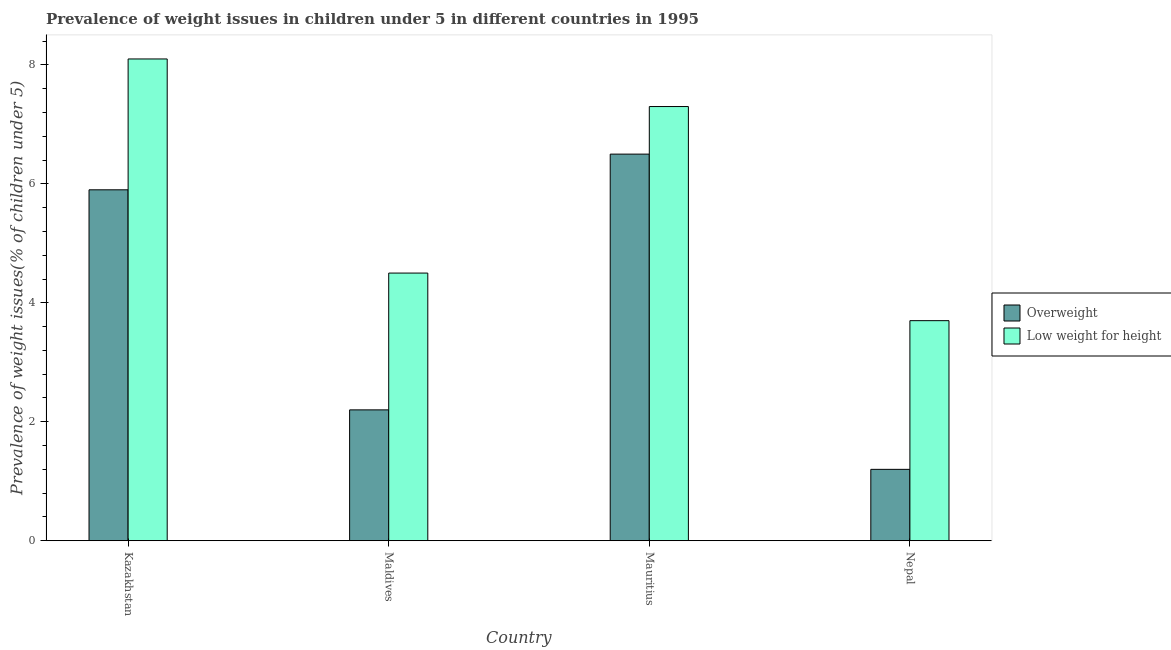How many different coloured bars are there?
Ensure brevity in your answer.  2. Are the number of bars per tick equal to the number of legend labels?
Provide a succinct answer. Yes. How many bars are there on the 4th tick from the right?
Offer a very short reply. 2. What is the label of the 1st group of bars from the left?
Make the answer very short. Kazakhstan. What is the percentage of underweight children in Nepal?
Provide a short and direct response. 3.7. Across all countries, what is the minimum percentage of underweight children?
Provide a short and direct response. 3.7. In which country was the percentage of overweight children maximum?
Give a very brief answer. Mauritius. In which country was the percentage of overweight children minimum?
Provide a succinct answer. Nepal. What is the total percentage of underweight children in the graph?
Provide a short and direct response. 23.6. What is the difference between the percentage of overweight children in Kazakhstan and that in Nepal?
Provide a succinct answer. 4.7. What is the difference between the percentage of overweight children in Maldives and the percentage of underweight children in Kazakhstan?
Ensure brevity in your answer.  -5.9. What is the average percentage of underweight children per country?
Your response must be concise. 5.9. What is the difference between the percentage of overweight children and percentage of underweight children in Mauritius?
Provide a short and direct response. -0.8. In how many countries, is the percentage of overweight children greater than 4.8 %?
Give a very brief answer. 2. What is the ratio of the percentage of overweight children in Mauritius to that in Nepal?
Provide a short and direct response. 5.42. Is the percentage of underweight children in Maldives less than that in Nepal?
Make the answer very short. No. Is the difference between the percentage of overweight children in Kazakhstan and Nepal greater than the difference between the percentage of underweight children in Kazakhstan and Nepal?
Provide a short and direct response. Yes. What is the difference between the highest and the second highest percentage of overweight children?
Offer a very short reply. 0.6. What is the difference between the highest and the lowest percentage of overweight children?
Offer a very short reply. 5.3. In how many countries, is the percentage of underweight children greater than the average percentage of underweight children taken over all countries?
Your answer should be compact. 2. What does the 2nd bar from the left in Nepal represents?
Keep it short and to the point. Low weight for height. What does the 2nd bar from the right in Mauritius represents?
Provide a short and direct response. Overweight. How many bars are there?
Give a very brief answer. 8. What is the difference between two consecutive major ticks on the Y-axis?
Your answer should be compact. 2. Are the values on the major ticks of Y-axis written in scientific E-notation?
Your response must be concise. No. Does the graph contain any zero values?
Provide a succinct answer. No. What is the title of the graph?
Your response must be concise. Prevalence of weight issues in children under 5 in different countries in 1995. Does "Official creditors" appear as one of the legend labels in the graph?
Provide a short and direct response. No. What is the label or title of the Y-axis?
Ensure brevity in your answer.  Prevalence of weight issues(% of children under 5). What is the Prevalence of weight issues(% of children under 5) of Overweight in Kazakhstan?
Your answer should be very brief. 5.9. What is the Prevalence of weight issues(% of children under 5) in Low weight for height in Kazakhstan?
Make the answer very short. 8.1. What is the Prevalence of weight issues(% of children under 5) of Overweight in Maldives?
Your answer should be very brief. 2.2. What is the Prevalence of weight issues(% of children under 5) of Low weight for height in Maldives?
Provide a short and direct response. 4.5. What is the Prevalence of weight issues(% of children under 5) in Overweight in Mauritius?
Your answer should be compact. 6.5. What is the Prevalence of weight issues(% of children under 5) in Low weight for height in Mauritius?
Ensure brevity in your answer.  7.3. What is the Prevalence of weight issues(% of children under 5) of Overweight in Nepal?
Ensure brevity in your answer.  1.2. What is the Prevalence of weight issues(% of children under 5) in Low weight for height in Nepal?
Make the answer very short. 3.7. Across all countries, what is the maximum Prevalence of weight issues(% of children under 5) of Overweight?
Offer a very short reply. 6.5. Across all countries, what is the maximum Prevalence of weight issues(% of children under 5) in Low weight for height?
Your answer should be compact. 8.1. Across all countries, what is the minimum Prevalence of weight issues(% of children under 5) of Overweight?
Keep it short and to the point. 1.2. Across all countries, what is the minimum Prevalence of weight issues(% of children under 5) of Low weight for height?
Offer a terse response. 3.7. What is the total Prevalence of weight issues(% of children under 5) of Low weight for height in the graph?
Ensure brevity in your answer.  23.6. What is the difference between the Prevalence of weight issues(% of children under 5) of Overweight in Kazakhstan and that in Maldives?
Offer a terse response. 3.7. What is the difference between the Prevalence of weight issues(% of children under 5) in Low weight for height in Kazakhstan and that in Maldives?
Ensure brevity in your answer.  3.6. What is the difference between the Prevalence of weight issues(% of children under 5) of Overweight in Kazakhstan and that in Mauritius?
Provide a succinct answer. -0.6. What is the difference between the Prevalence of weight issues(% of children under 5) of Low weight for height in Kazakhstan and that in Mauritius?
Ensure brevity in your answer.  0.8. What is the difference between the Prevalence of weight issues(% of children under 5) of Low weight for height in Kazakhstan and that in Nepal?
Your answer should be compact. 4.4. What is the difference between the Prevalence of weight issues(% of children under 5) in Low weight for height in Maldives and that in Nepal?
Offer a terse response. 0.8. What is the difference between the Prevalence of weight issues(% of children under 5) in Overweight in Kazakhstan and the Prevalence of weight issues(% of children under 5) in Low weight for height in Maldives?
Offer a very short reply. 1.4. What is the difference between the Prevalence of weight issues(% of children under 5) of Overweight in Kazakhstan and the Prevalence of weight issues(% of children under 5) of Low weight for height in Nepal?
Make the answer very short. 2.2. What is the difference between the Prevalence of weight issues(% of children under 5) of Overweight in Maldives and the Prevalence of weight issues(% of children under 5) of Low weight for height in Mauritius?
Your answer should be very brief. -5.1. What is the average Prevalence of weight issues(% of children under 5) of Overweight per country?
Your answer should be very brief. 3.95. What is the difference between the Prevalence of weight issues(% of children under 5) in Overweight and Prevalence of weight issues(% of children under 5) in Low weight for height in Maldives?
Provide a short and direct response. -2.3. What is the ratio of the Prevalence of weight issues(% of children under 5) in Overweight in Kazakhstan to that in Maldives?
Provide a succinct answer. 2.68. What is the ratio of the Prevalence of weight issues(% of children under 5) of Overweight in Kazakhstan to that in Mauritius?
Keep it short and to the point. 0.91. What is the ratio of the Prevalence of weight issues(% of children under 5) of Low weight for height in Kazakhstan to that in Mauritius?
Keep it short and to the point. 1.11. What is the ratio of the Prevalence of weight issues(% of children under 5) of Overweight in Kazakhstan to that in Nepal?
Offer a very short reply. 4.92. What is the ratio of the Prevalence of weight issues(% of children under 5) of Low weight for height in Kazakhstan to that in Nepal?
Keep it short and to the point. 2.19. What is the ratio of the Prevalence of weight issues(% of children under 5) in Overweight in Maldives to that in Mauritius?
Offer a terse response. 0.34. What is the ratio of the Prevalence of weight issues(% of children under 5) in Low weight for height in Maldives to that in Mauritius?
Keep it short and to the point. 0.62. What is the ratio of the Prevalence of weight issues(% of children under 5) in Overweight in Maldives to that in Nepal?
Keep it short and to the point. 1.83. What is the ratio of the Prevalence of weight issues(% of children under 5) of Low weight for height in Maldives to that in Nepal?
Your answer should be very brief. 1.22. What is the ratio of the Prevalence of weight issues(% of children under 5) of Overweight in Mauritius to that in Nepal?
Ensure brevity in your answer.  5.42. What is the ratio of the Prevalence of weight issues(% of children under 5) of Low weight for height in Mauritius to that in Nepal?
Your answer should be very brief. 1.97. What is the difference between the highest and the second highest Prevalence of weight issues(% of children under 5) in Overweight?
Provide a succinct answer. 0.6. What is the difference between the highest and the second highest Prevalence of weight issues(% of children under 5) in Low weight for height?
Ensure brevity in your answer.  0.8. What is the difference between the highest and the lowest Prevalence of weight issues(% of children under 5) of Overweight?
Offer a very short reply. 5.3. 